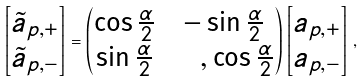<formula> <loc_0><loc_0><loc_500><loc_500>\begin{bmatrix} \tilde { a } _ { p , + } \\ \tilde { a } _ { p , - } \end{bmatrix} = \begin{pmatrix} \cos \frac { \alpha } { 2 } & - \sin \frac { \alpha } { 2 } \\ \sin \frac { \alpha } { 2 } & \quad , \cos \frac { \alpha } { 2 } \end{pmatrix} \begin{bmatrix} a _ { p , + } \\ a _ { p , - } \end{bmatrix} \, ,</formula> 